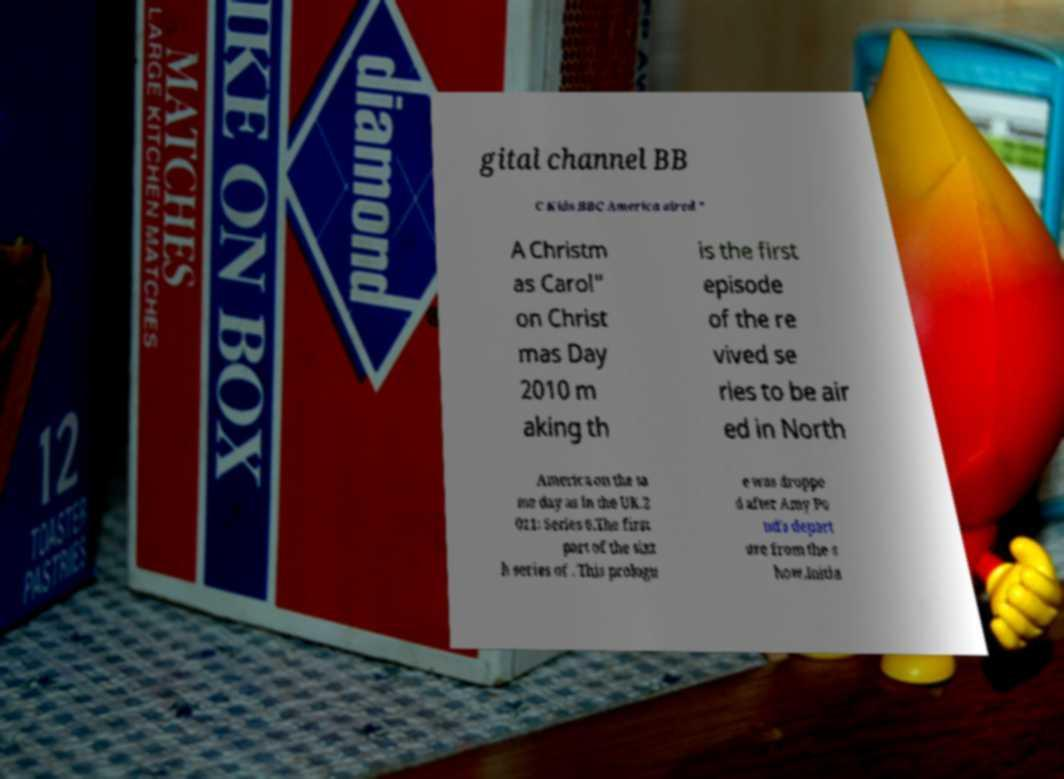Could you assist in decoding the text presented in this image and type it out clearly? gital channel BB C Kids.BBC America aired " A Christm as Carol" on Christ mas Day 2010 m aking th is the first episode of the re vived se ries to be air ed in North America on the sa me day as in the UK.2 011: Series 6.The first part of the sixt h series of . This prologu e was droppe d after Amy Po nd's depart ure from the s how.Initia 